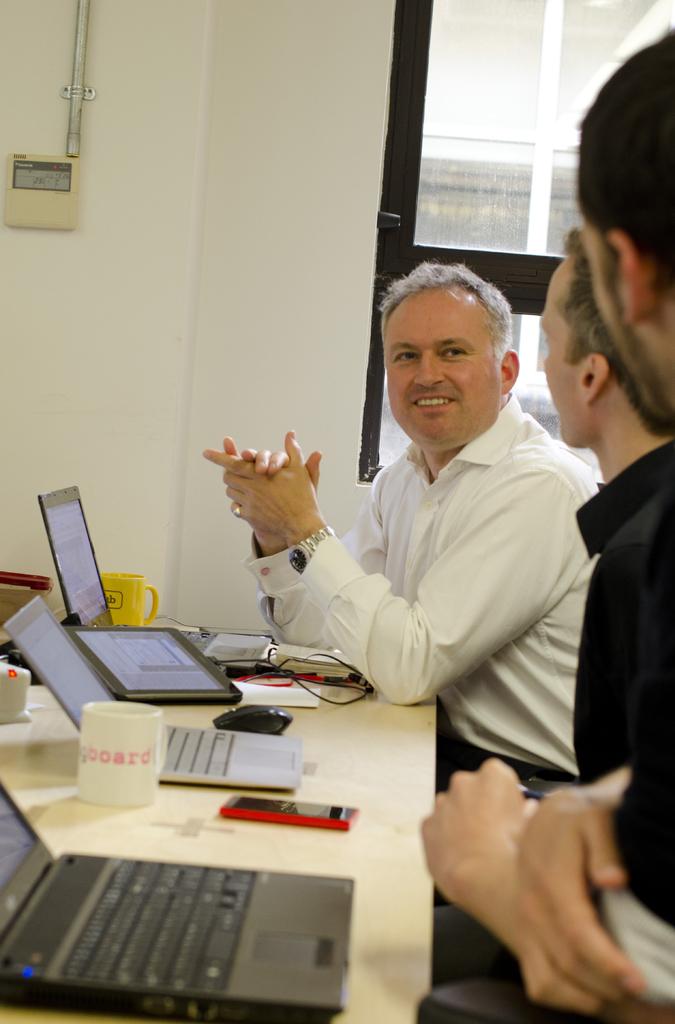What's on the white mug?
Your response must be concise. Board. 